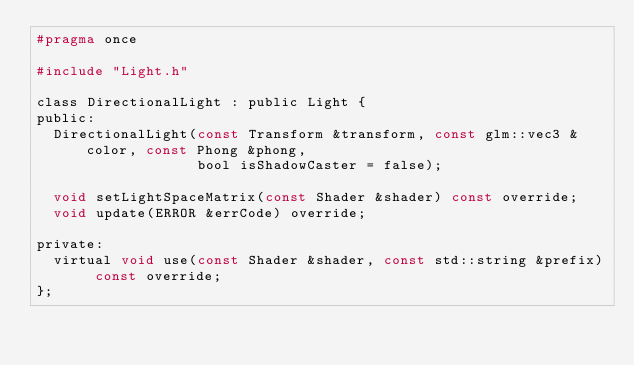<code> <loc_0><loc_0><loc_500><loc_500><_C_>#pragma once

#include "Light.h"

class DirectionalLight : public Light {
public:
  DirectionalLight(const Transform &transform, const glm::vec3 &color, const Phong &phong,
                   bool isShadowCaster = false);

  void setLightSpaceMatrix(const Shader &shader) const override;
  void update(ERROR &errCode) override;

private:
  virtual void use(const Shader &shader, const std::string &prefix) const override;
};</code> 